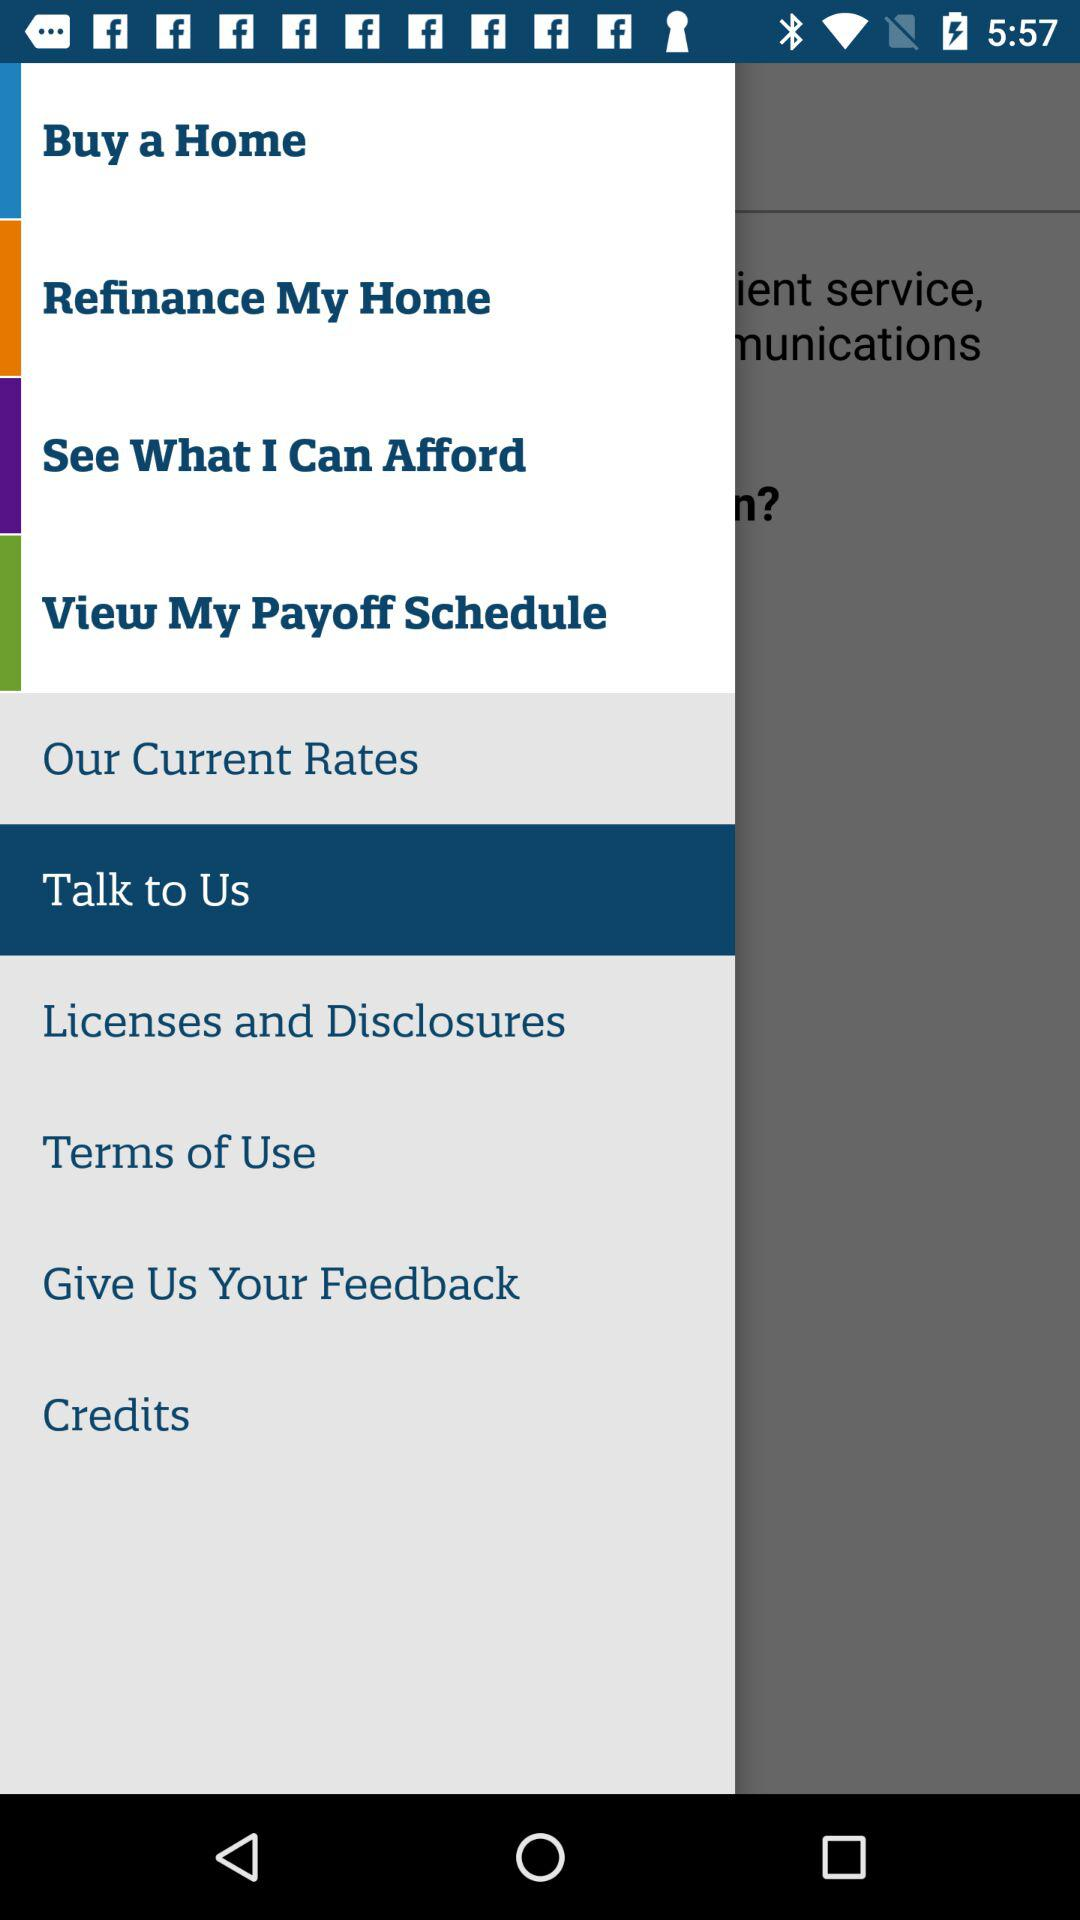What is the selected item? The selected item is "Talk to Us". 